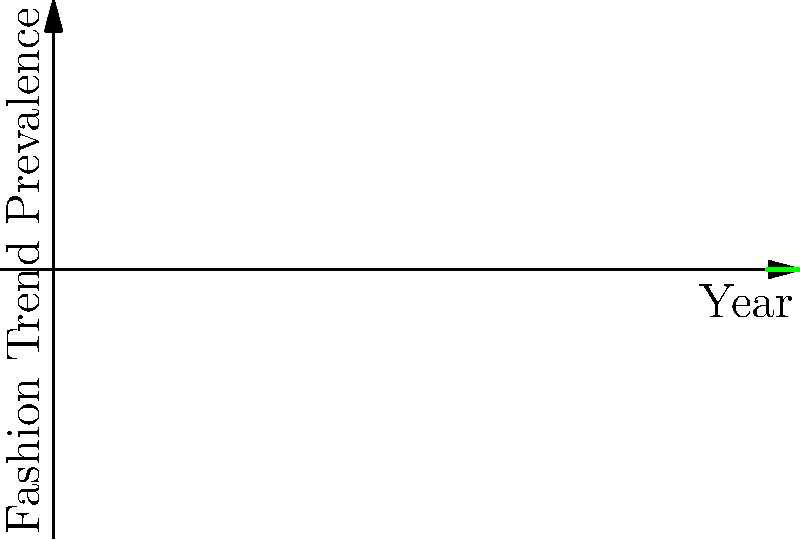In a collection of family letters, you find a mention of "utility clothing" becoming popular. Based on the fashion trend graph, approximately which year would you estimate this letter was written? To determine the approximate year when "utility clothing" became popular, we need to analyze the graph:

1. Identify the curve: The green curve represents "Utility Clothing".
2. Find the peak: The highest point of the green curve indicates when utility clothing was most prevalent.
3. Locate the year: The peak of the green curve aligns with approximately 1940 on the x-axis.
4. Consider context: Utility clothing became popular during World War II due to rationing and practicality.
5. Verify with other trends: The decline of flapper dresses (blue curve) and the much earlier peak of corsets (red curve) support this timeline.
6. Conclusion: The letter mentioning the popularity of utility clothing was likely written around 1940.
Answer: 1940 